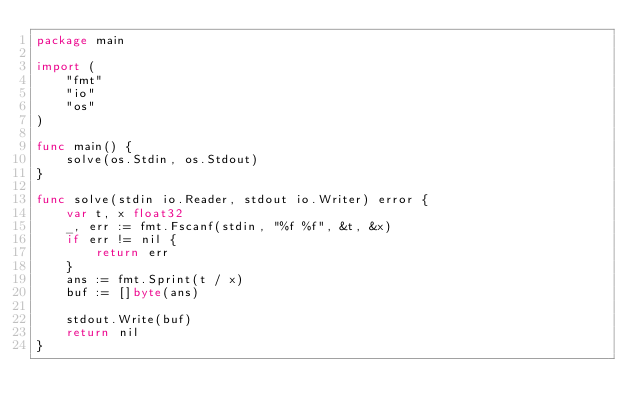<code> <loc_0><loc_0><loc_500><loc_500><_Go_>package main

import (
	"fmt"
	"io"
	"os"
)

func main() {
	solve(os.Stdin, os.Stdout)
}

func solve(stdin io.Reader, stdout io.Writer) error {
	var t, x float32
	_, err := fmt.Fscanf(stdin, "%f %f", &t, &x)
	if err != nil {
		return err
	}
	ans := fmt.Sprint(t / x)
	buf := []byte(ans)

	stdout.Write(buf)
	return nil
}
</code> 